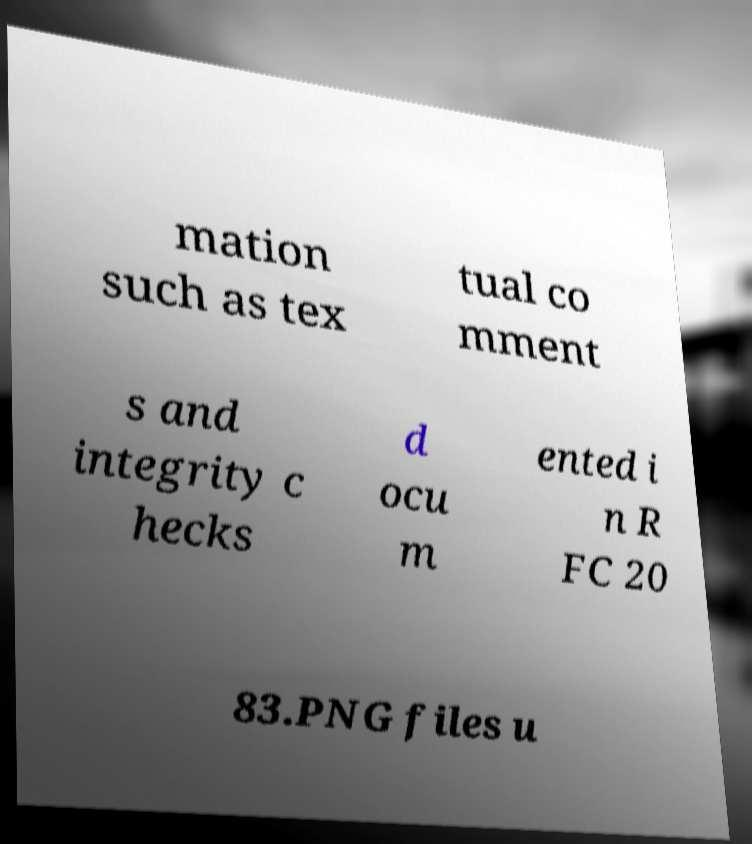I need the written content from this picture converted into text. Can you do that? mation such as tex tual co mment s and integrity c hecks d ocu m ented i n R FC 20 83.PNG files u 